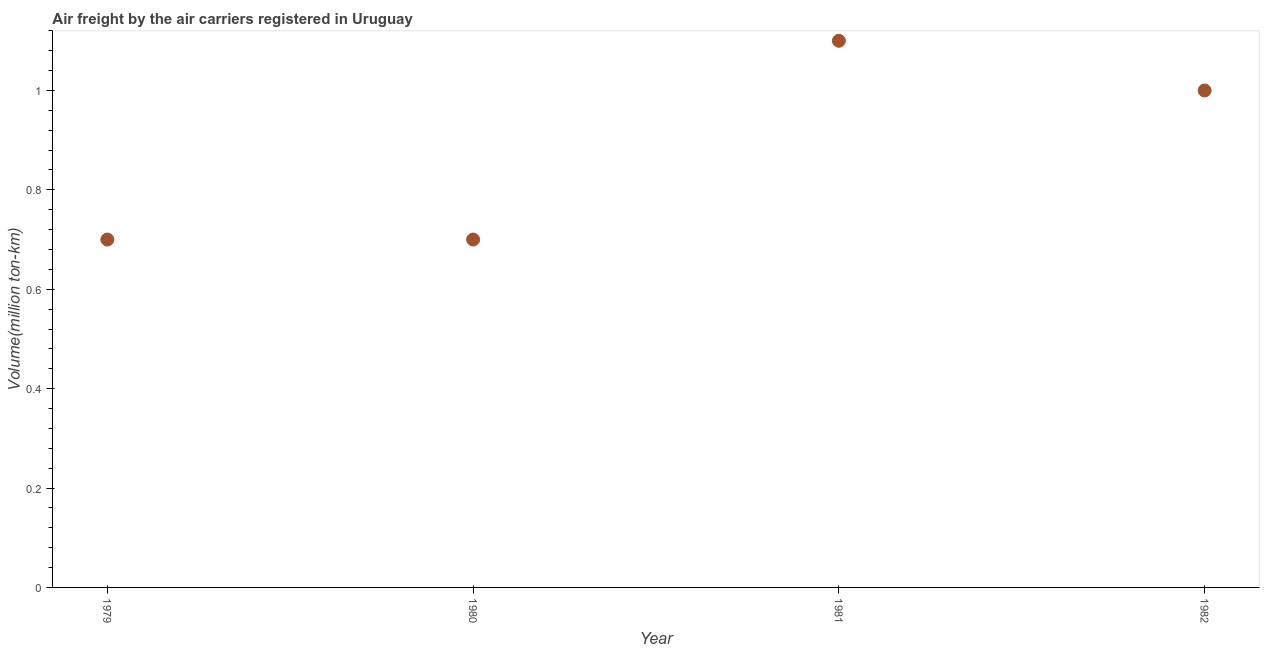What is the air freight in 1979?
Offer a terse response. 0.7. Across all years, what is the maximum air freight?
Provide a succinct answer. 1.1. Across all years, what is the minimum air freight?
Ensure brevity in your answer.  0.7. In which year was the air freight minimum?
Provide a short and direct response. 1979. What is the sum of the air freight?
Your answer should be compact. 3.5. What is the difference between the air freight in 1979 and 1981?
Keep it short and to the point. -0.4. What is the average air freight per year?
Offer a terse response. 0.88. What is the median air freight?
Provide a succinct answer. 0.85. In how many years, is the air freight greater than 0.68 million ton-km?
Ensure brevity in your answer.  4. What is the ratio of the air freight in 1981 to that in 1982?
Ensure brevity in your answer.  1.1. Is the air freight in 1980 less than that in 1982?
Make the answer very short. Yes. What is the difference between the highest and the second highest air freight?
Provide a short and direct response. 0.1. What is the difference between the highest and the lowest air freight?
Your answer should be compact. 0.4. In how many years, is the air freight greater than the average air freight taken over all years?
Give a very brief answer. 2. Does the air freight monotonically increase over the years?
Make the answer very short. No. Does the graph contain any zero values?
Ensure brevity in your answer.  No. What is the title of the graph?
Make the answer very short. Air freight by the air carriers registered in Uruguay. What is the label or title of the Y-axis?
Give a very brief answer. Volume(million ton-km). What is the Volume(million ton-km) in 1979?
Your answer should be compact. 0.7. What is the Volume(million ton-km) in 1980?
Keep it short and to the point. 0.7. What is the Volume(million ton-km) in 1981?
Ensure brevity in your answer.  1.1. What is the difference between the Volume(million ton-km) in 1979 and 1980?
Keep it short and to the point. 0. What is the difference between the Volume(million ton-km) in 1979 and 1981?
Provide a succinct answer. -0.4. What is the difference between the Volume(million ton-km) in 1979 and 1982?
Ensure brevity in your answer.  -0.3. What is the difference between the Volume(million ton-km) in 1981 and 1982?
Give a very brief answer. 0.1. What is the ratio of the Volume(million ton-km) in 1979 to that in 1981?
Your answer should be very brief. 0.64. What is the ratio of the Volume(million ton-km) in 1979 to that in 1982?
Your response must be concise. 0.7. What is the ratio of the Volume(million ton-km) in 1980 to that in 1981?
Provide a succinct answer. 0.64. 